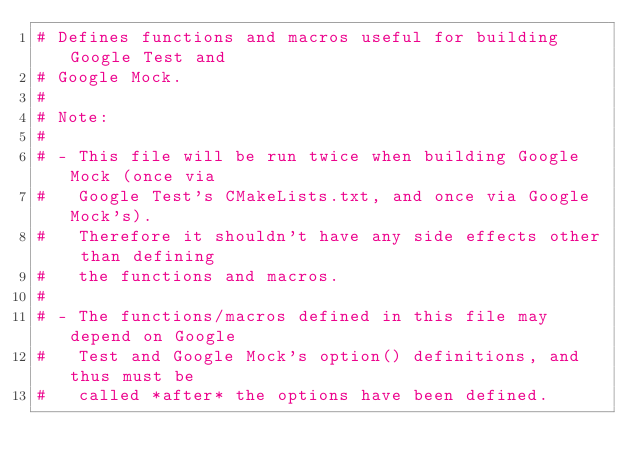Convert code to text. <code><loc_0><loc_0><loc_500><loc_500><_CMake_># Defines functions and macros useful for building Google Test and
# Google Mock.
#
# Note:
#
# - This file will be run twice when building Google Mock (once via
#   Google Test's CMakeLists.txt, and once via Google Mock's).
#   Therefore it shouldn't have any side effects other than defining
#   the functions and macros.
#
# - The functions/macros defined in this file may depend on Google
#   Test and Google Mock's option() definitions, and thus must be
#   called *after* the options have been defined.
</code> 